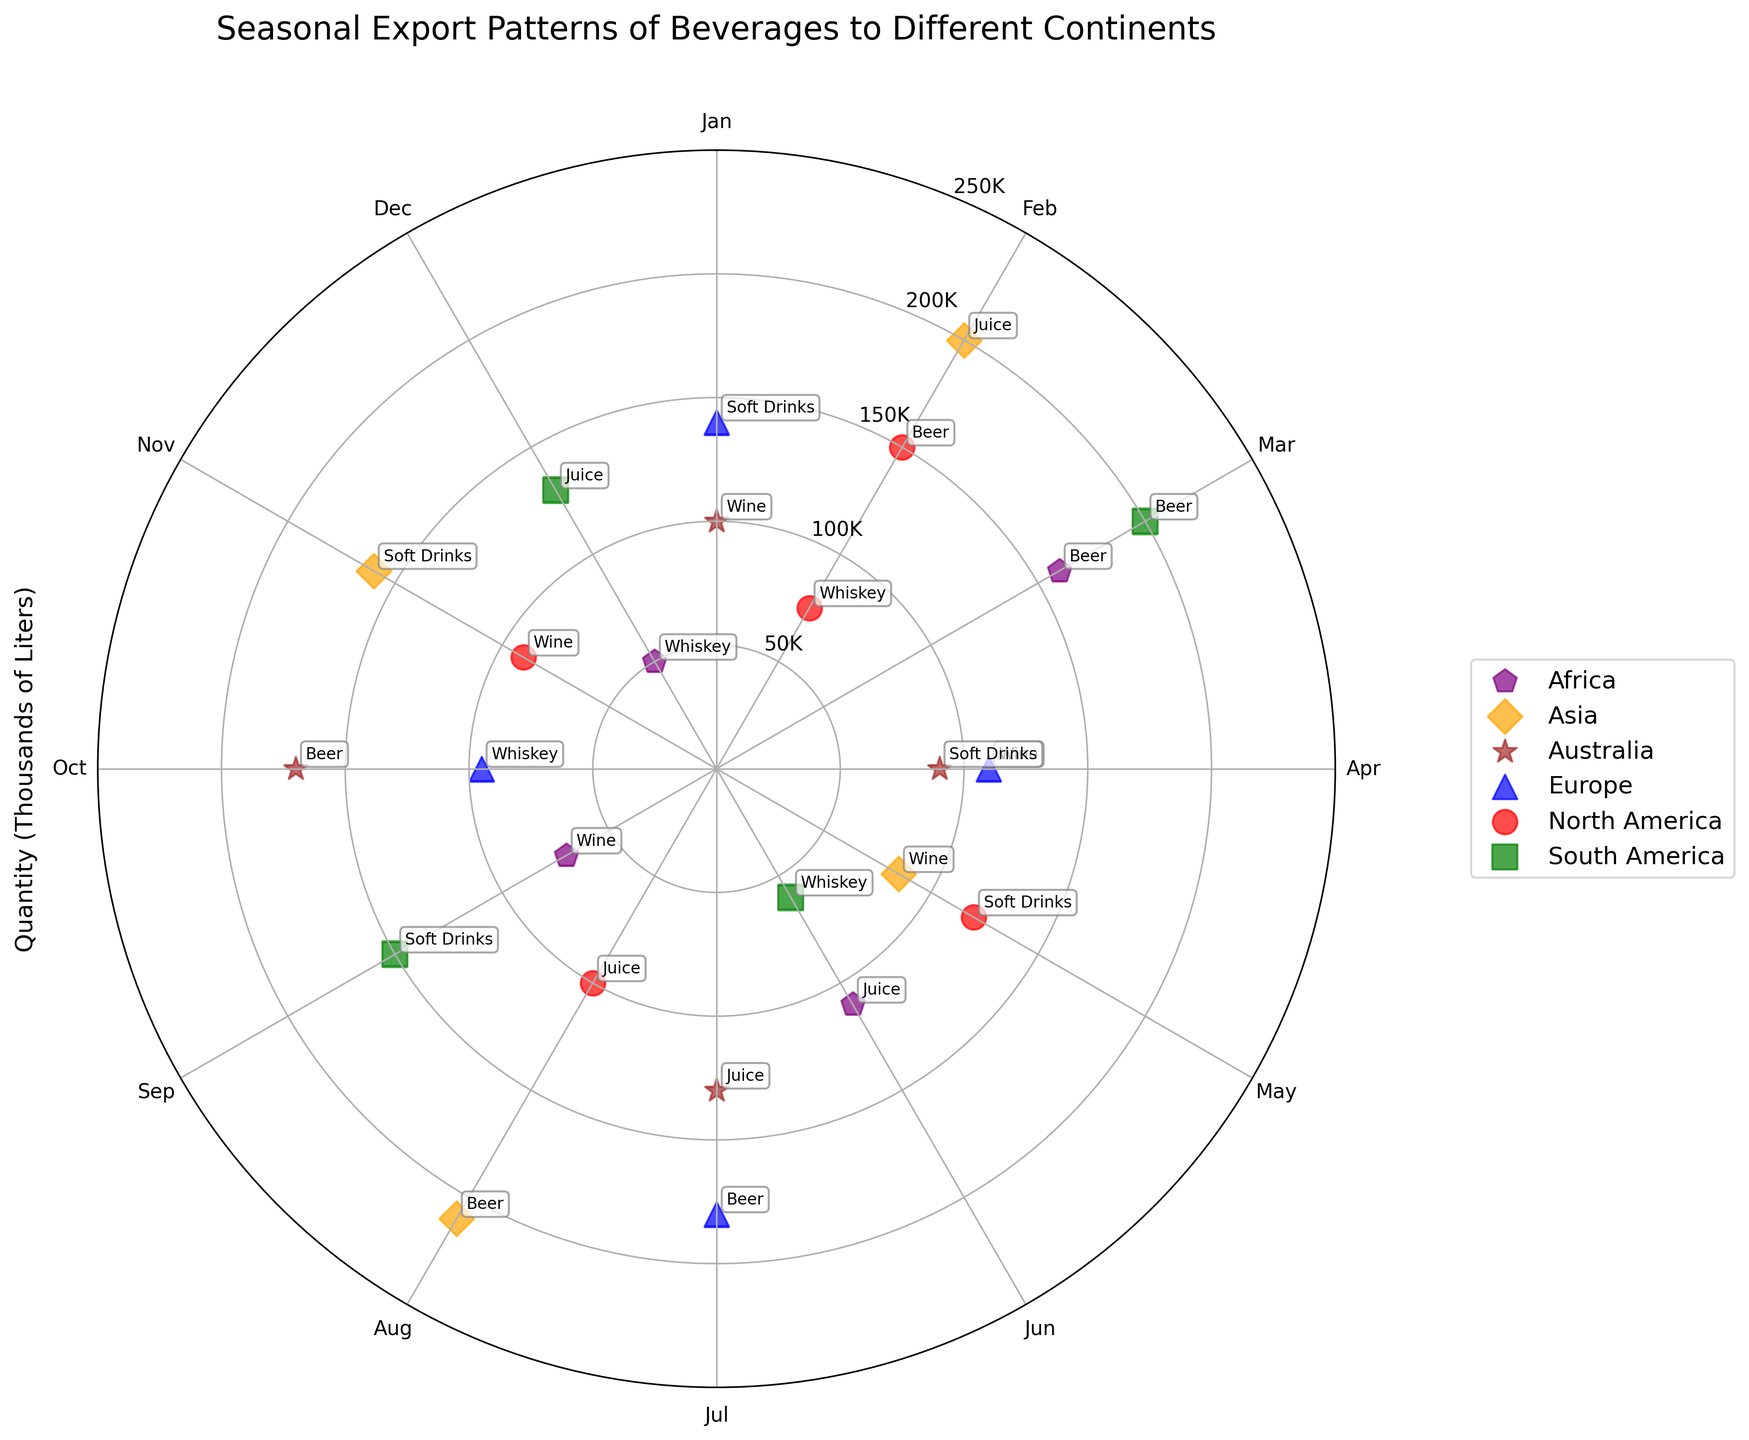Which continent has the highest quantity of beer exports? To find the continent with the highest quantity of beer exports, look for the highest data point associated with beer (identified by annotations) on the plot. Asia has a beer export quantity of 210K liters in July, which is the highest among all continents.
Answer: Asia What month represents the peak export of juice in North America? Identify the juice export data point on the plot for North America. In North America, the export of juice reaches its peak at 100,000 liters in the month of July.
Answer: July Which continent has the most diverse range of beverage types exported across different months? Observe the scatter plot to see which continent has the most different types of beverages (identified by annotations) distributed throughout different months. North America has data points for beer, whiskey, soft drinks, juice, and wine, showing the most diverse range.
Answer: North America For which beverage and continent combination is the lowest quantity exported, and what is the quantity? Identify the smallest data point on the scatter plot for each beverage and continent combination. The plot indicates that Africa exports the lowest quantity of whiskey in November, with a quantity of 50,000 liters.
Answer: Whiskey in Africa, 50,000 liters In which month does Europe have the highest export quantity, and for which beverage? Locate the highest data point for Europe on the scatter plot and check the corresponding month and beverage annotation. Europe has its highest export quantity in June for beer, with 180,000 liters.
Answer: June, Beer Compare the export quantities of wine for Europe and North America. Which continent exports more, and by how much? Look for the data points labeled "wine" in Europe and North America and compare their quantities. Europe exports 110K liters of wine in March, while North America exports 90K liters of wine in October. Europe exports 20K liters more wine than North America.
Answer: Europe, 20,000 liters What beverage has the highest quantity of exports in November, and to which continent? Identify the largest data point in November by checking the annotations. South America exports the highest quantity in November, with 130,000 liters of juice.
Answer: Juice, South America How does the quantity of soft drinks exported to Asia in October compare to soft drinks exported to Europe in December? Locate the data points labeled "soft drinks" for Asia in October and Europe in December and compare their quantities. Asia exports 160K liters of soft drinks in October, while Europe exports 140K liters of soft drinks in December. Asia exports more soft drinks.
Answer: Asia exports more What is the average export quantity of beverages to Africa in February and May? Find the export quantities for Africa in February and May. Beer is exported in February (160K liters) and juice in May (110K liters). Calculate the average: (160 + 110) / 2 = 135K liters.
Answer: 135,000 liters Which continent exports whiskey in September and November, and what are the quantities for each month? Identify data points labeled "whiskey" in September and November. Europe exports whiskey in September (95K liters) and Africa exports whiskey in November (50K liters).
Answer: Europe (95K liters), Africa (50K liters) 